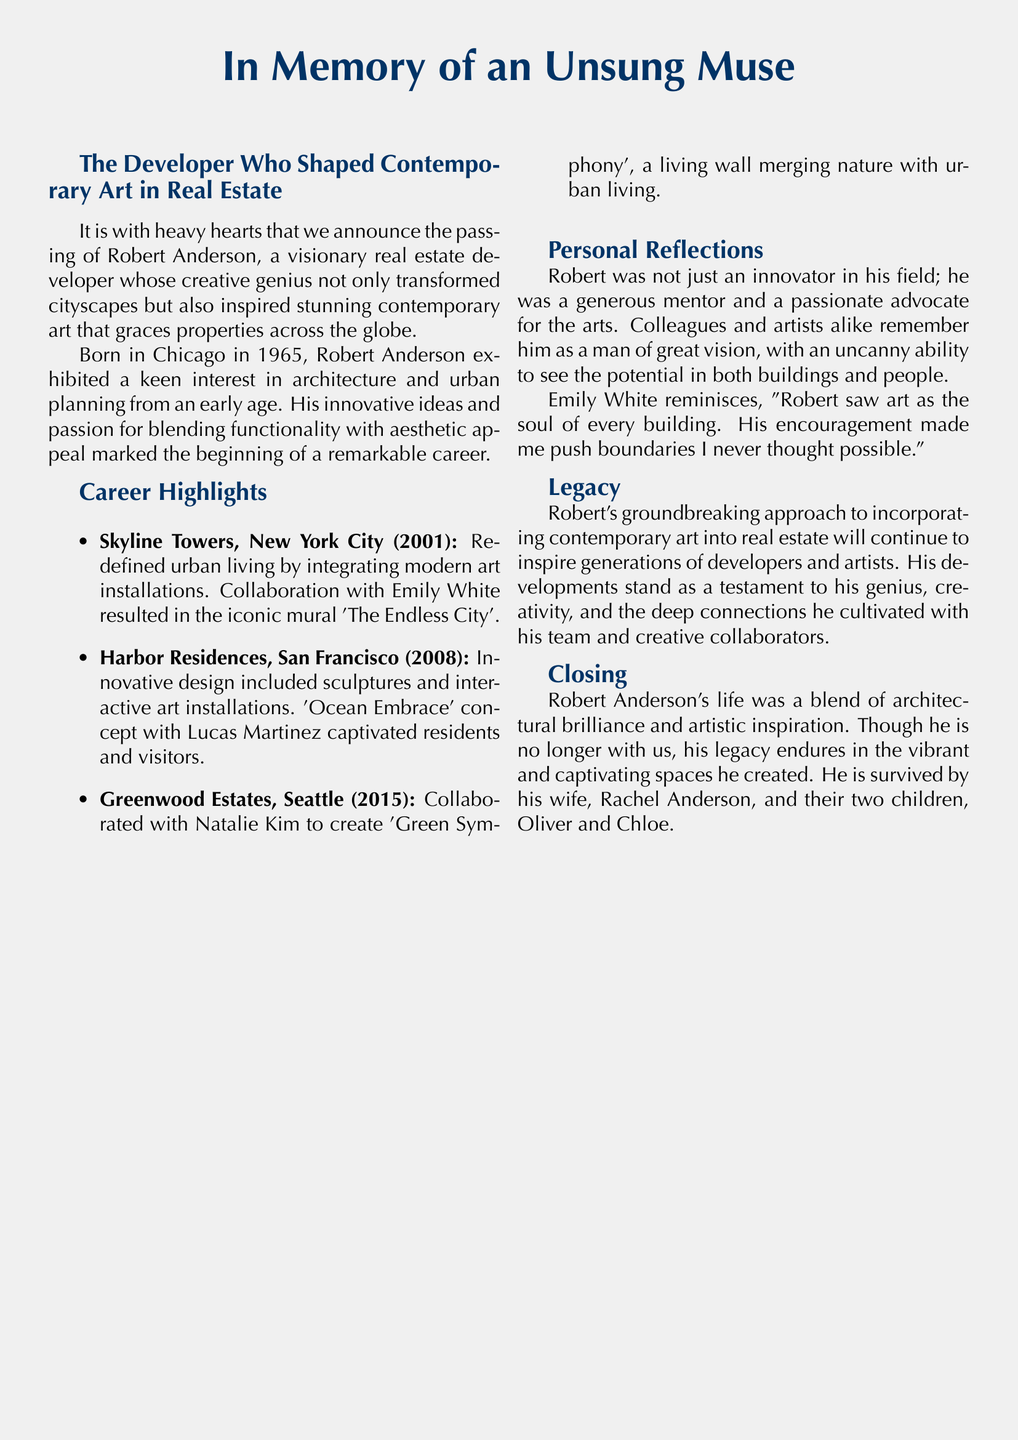what is the full name of the developer? The document states the developer's name as Robert Anderson.
Answer: Robert Anderson when was Robert Anderson born? The document mentions that Robert Anderson was born in 1965.
Answer: 1965 what is the title of the mural created in collaboration with Emily White? The document lists the mural 'The Endless City' as the creation with Emily White.
Answer: The Endless City how many children did Robert Anderson have? The document states that Robert Anderson is survived by two children.
Answer: two which city did the Skyline Towers project take place? The document indicates that the Skyline Towers project was located in New York City.
Answer: New York City what type of installations did Robert Anderson incorporate in Harbor Residences? The document describes sculptures and interactive art installations as part of the Harbor Residences project.
Answer: sculptures and interactive art installations who expressed a reflection about Robert seeing art as the soul of every building? The document cites Emily White as the person reflecting on Robert's vision of art.
Answer: Emily White what was Robert Anderson's profession? The document refers to him as a visionary real estate developer.
Answer: real estate developer what is the legacy of Robert Anderson according to the document? The document mentions his groundbreaking approach to incorporating contemporary art in real estate as his legacy.
Answer: groundbreaking approach to incorporating contemporary art in real estate 